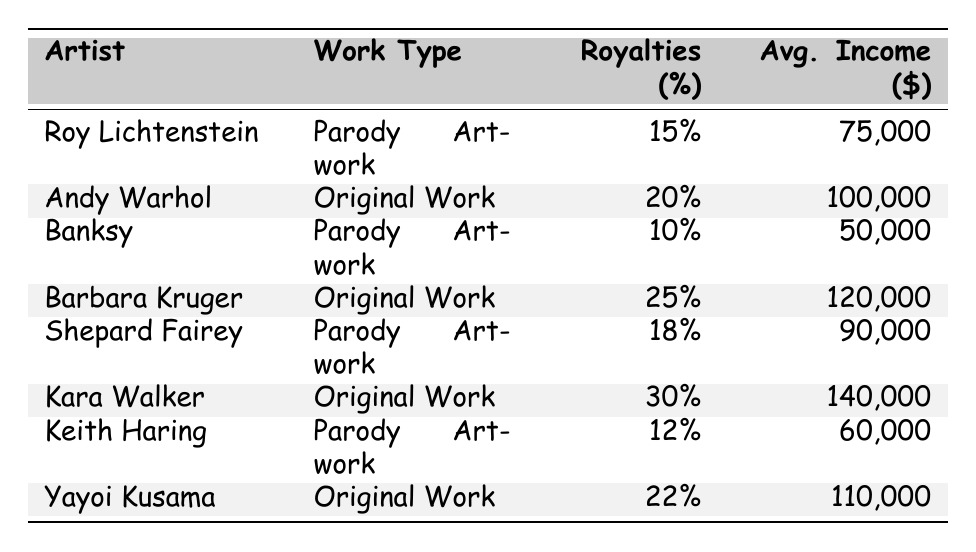What are the royalties percentage for Roy Lichtenstein's Parody Artwork? The table lists Roy Lichtenstein's work type as Parody Artwork, with a royalties percentage of 15%.
Answer: 15% Which artist has the highest average income from their work? By comparing the average incomes listed, Kara Walker has the highest average income of $140,000.
Answer: $140,000 How much does Banksy earn on average from his Parody Artwork? The table shows Banksy's average income from Parody Artwork is $50,000.
Answer: $50,000 What is the difference in royalties percentage between Barbara Kruger and Keith Haring? Barbara Kruger has a royalties percentage of 25%, while Keith Haring has 12%. The difference is 25% - 12% = 13%.
Answer: 13% Is the royalties percentage for any artist's Original Work higher than 25%? Yes, both Barbara Kruger (25%) and Kara Walker (30%) have a royalties percentage that is equal to or higher than 25%.
Answer: Yes Calculate the average royalties percentage for Parody Artwork. The royalties percentages for Parody Artwork are 15%, 10%, 18%, and 12%. The average is calculated as (15 + 10 + 18 + 12) / 4 = 55 / 4 = 13.75%.
Answer: 13.75% Which type of work has a higher average income: Original Works or Parody Artworks? The average income for Original Works (100,000 + 120,000 + 140,000 + 110,000) / 4 = 117,500, while for Parody Artworks (75,000 + 50,000 + 90,000 + 60,000) / 4 = 68,750. Since 117,500 > 68,750, Original Works have a higher average income.
Answer: Original Works How many artists created Parody Artwork? The table lists four artists who created Parody Artwork: Roy Lichtenstein, Banksy, Shepard Fairey, and Keith Haring.
Answer: 4 What is the average income for Original Works? The average income for Original Works is calculated as (100,000 + 120,000 + 140,000 + 110,000) / 4 = 117,500.
Answer: 117,500 Which artist has the lowest average income among the listed parody artists? The average income for parody artists listed is $75,000 (Roy Lichtenstein), $50,000 (Banksy), $90,000 (Shepard Fairey), and $60,000 (Keith Haring). Banksy has the lowest at $50,000.
Answer: Banksy 